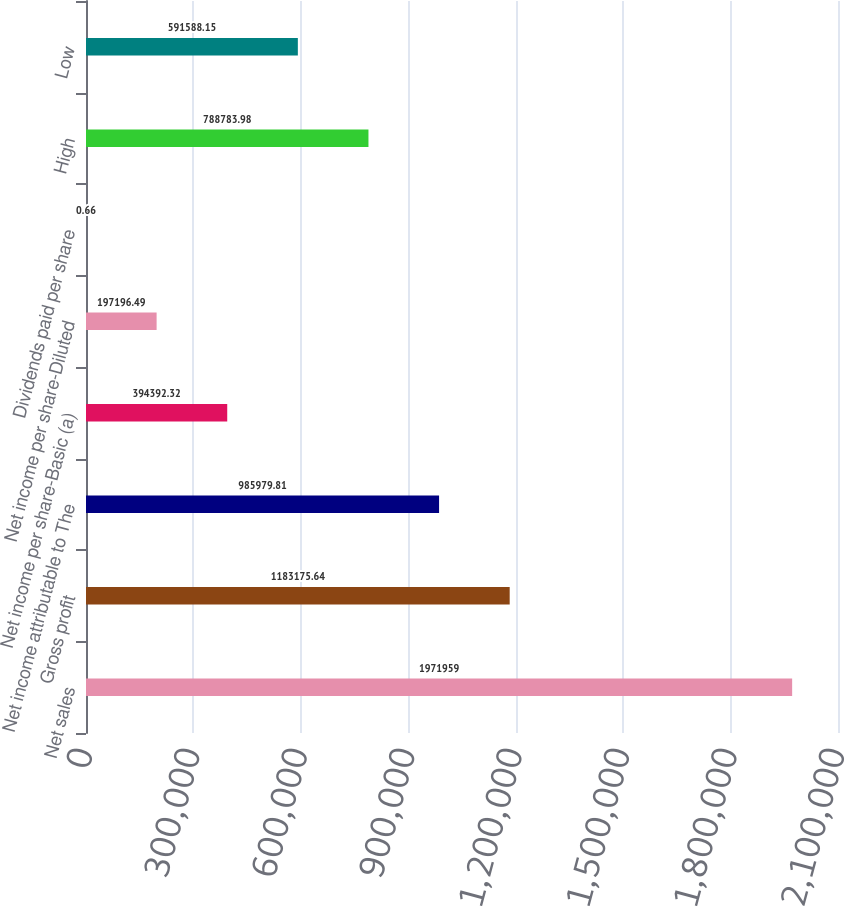Convert chart. <chart><loc_0><loc_0><loc_500><loc_500><bar_chart><fcel>Net sales<fcel>Gross profit<fcel>Net income attributable to The<fcel>Net income per share-Basic (a)<fcel>Net income per share-Diluted<fcel>Dividends paid per share<fcel>High<fcel>Low<nl><fcel>1.97196e+06<fcel>1.18318e+06<fcel>985980<fcel>394392<fcel>197196<fcel>0.66<fcel>788784<fcel>591588<nl></chart> 